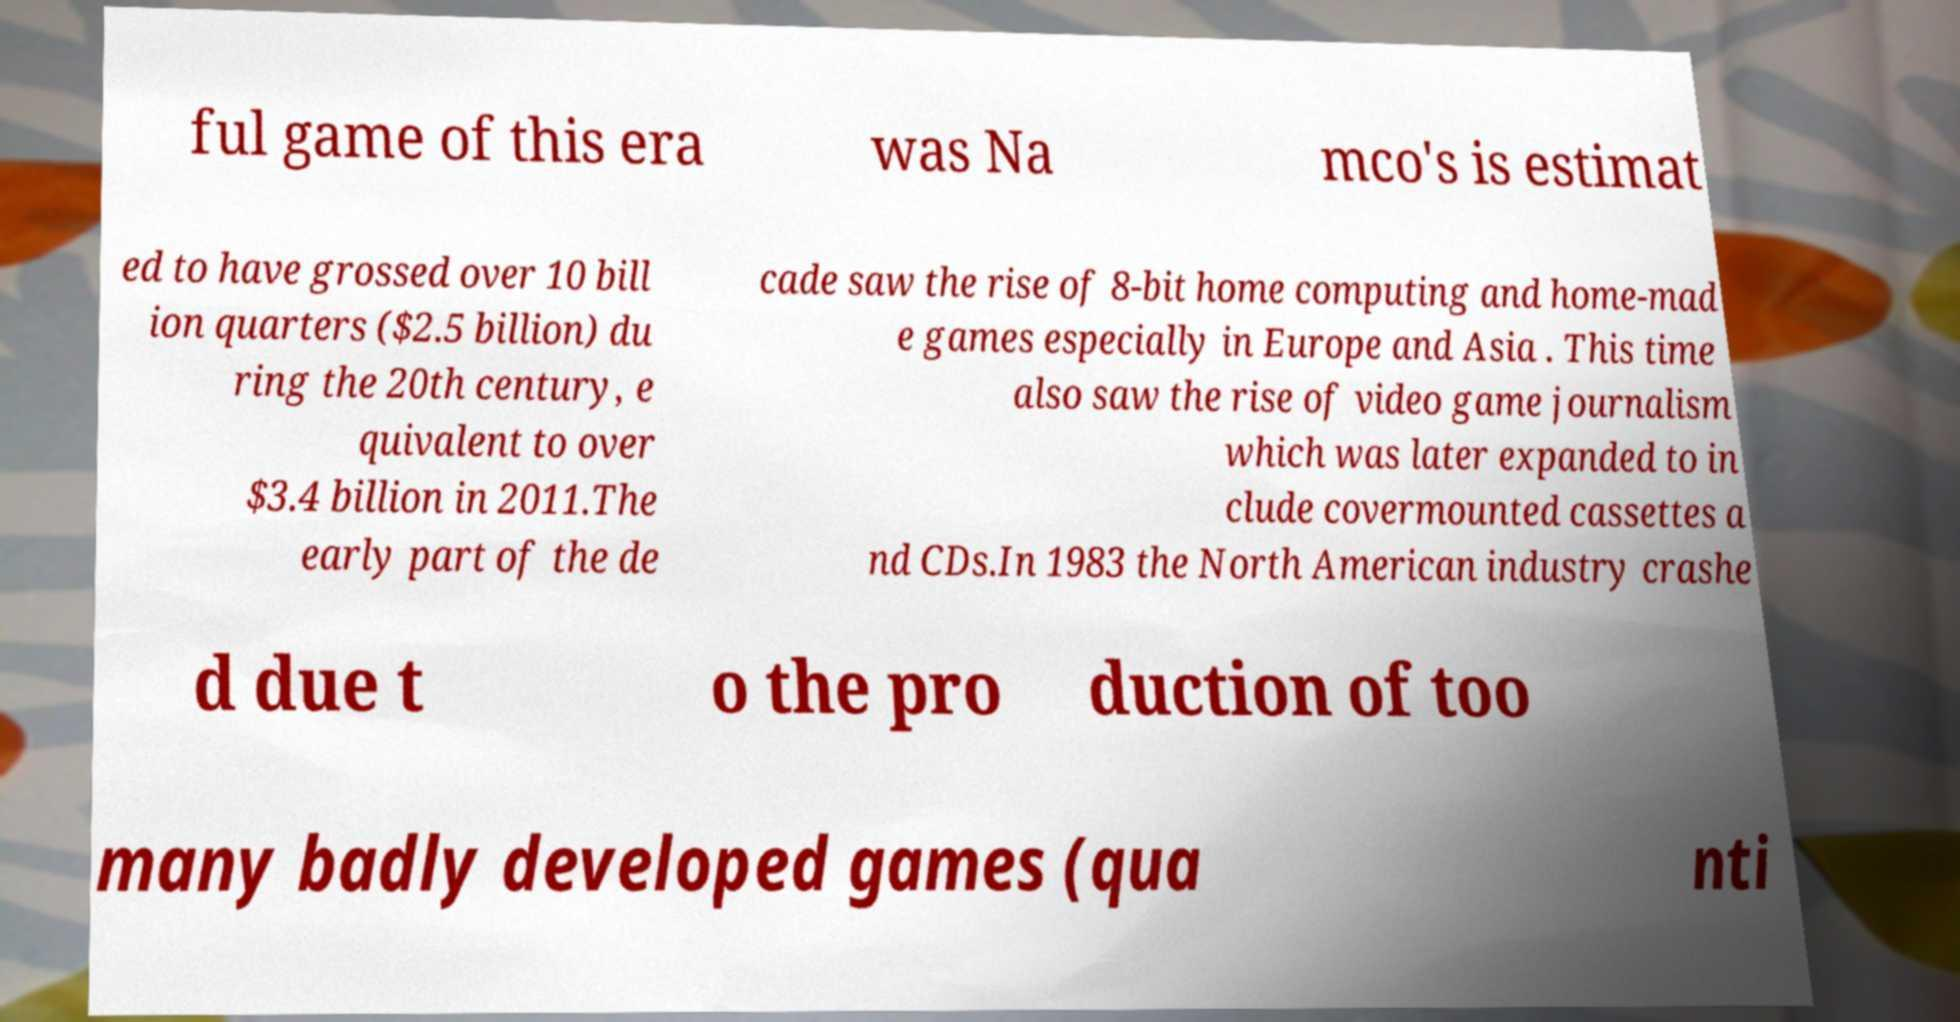I need the written content from this picture converted into text. Can you do that? ful game of this era was Na mco's is estimat ed to have grossed over 10 bill ion quarters ($2.5 billion) du ring the 20th century, e quivalent to over $3.4 billion in 2011.The early part of the de cade saw the rise of 8-bit home computing and home-mad e games especially in Europe and Asia . This time also saw the rise of video game journalism which was later expanded to in clude covermounted cassettes a nd CDs.In 1983 the North American industry crashe d due t o the pro duction of too many badly developed games (qua nti 